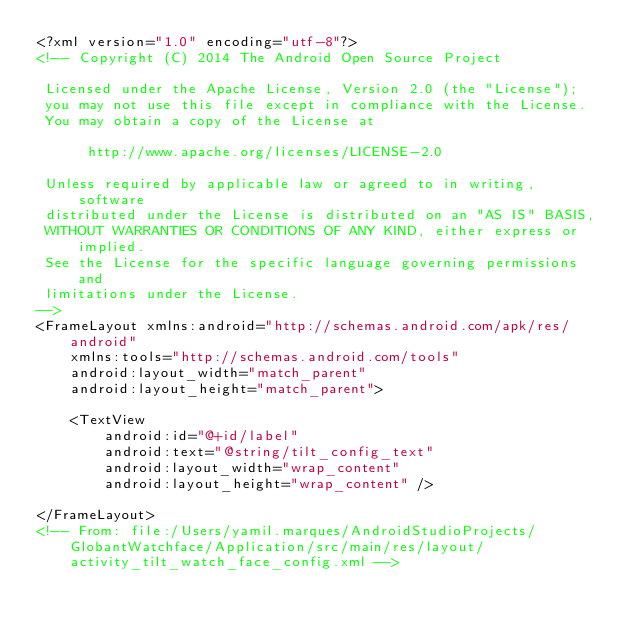<code> <loc_0><loc_0><loc_500><loc_500><_XML_><?xml version="1.0" encoding="utf-8"?>
<!-- Copyright (C) 2014 The Android Open Source Project

 Licensed under the Apache License, Version 2.0 (the "License");
 you may not use this file except in compliance with the License.
 You may obtain a copy of the License at

      http://www.apache.org/licenses/LICENSE-2.0

 Unless required by applicable law or agreed to in writing, software
 distributed under the License is distributed on an "AS IS" BASIS,
 WITHOUT WARRANTIES OR CONDITIONS OF ANY KIND, either express or implied.
 See the License for the specific language governing permissions and
 limitations under the License.
-->
<FrameLayout xmlns:android="http://schemas.android.com/apk/res/android"
    xmlns:tools="http://schemas.android.com/tools"
    android:layout_width="match_parent"
    android:layout_height="match_parent">

    <TextView
        android:id="@+id/label"
        android:text="@string/tilt_config_text"
        android:layout_width="wrap_content"
        android:layout_height="wrap_content" />

</FrameLayout>
<!-- From: file:/Users/yamil.marques/AndroidStudioProjects/GlobantWatchface/Application/src/main/res/layout/activity_tilt_watch_face_config.xml --></code> 